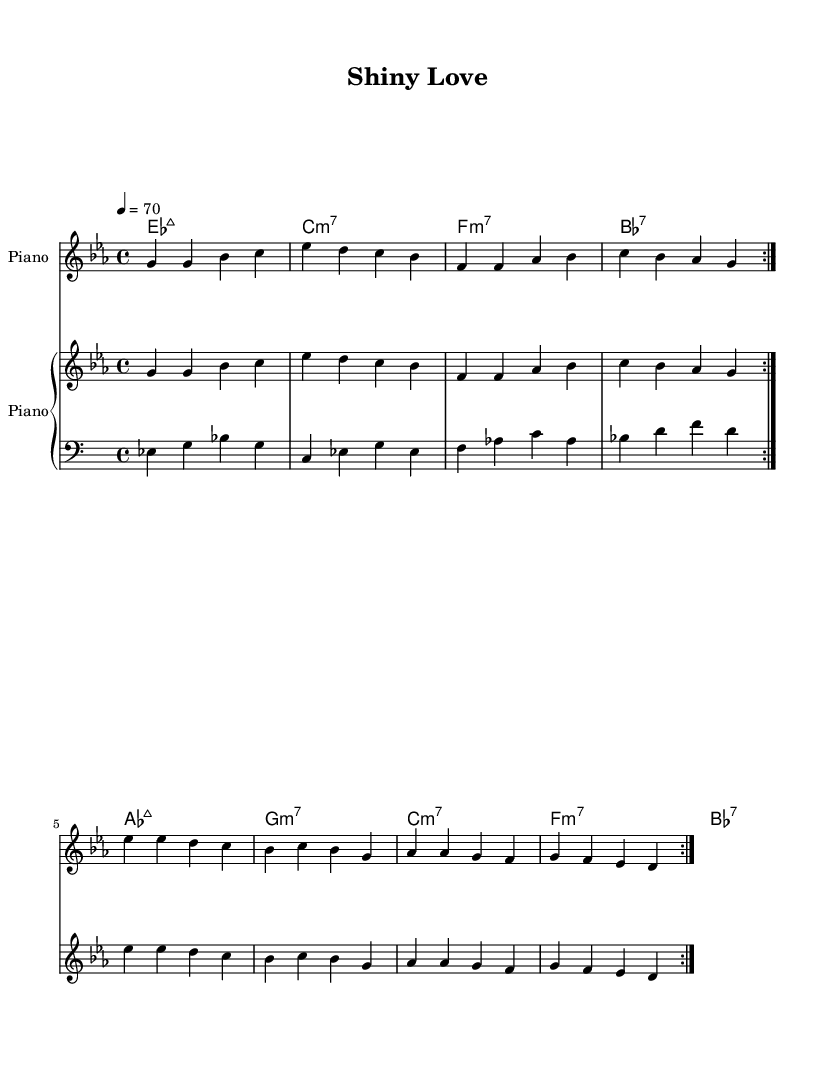What is the key signature of this music? The key signature is indicated at the beginning of the score. A sigil with three flats (B, E, and A) suggests the presence of these flats in the key.
Answer: E flat major What is the time signature of this music? The time signature is displayed at the start of the score, showing a fraction of 4 over 4. This indicates that there are four beats in each measure, and the quarter note receives one beat.
Answer: 4/4 What is the tempo marking for this piece? The tempo marking indicates how fast the piece should be played. Here, it is displayed as a metronomic marking of 70 beats per minute.
Answer: 70 How many times is the main melody repeated? The "repeat volta" notation indicates that the main melody section is played twice in succession. This is specified in the score prior to the melody part.
Answer: 2 What chord starts the music? The chord names are listed above the melody staff. The first chord is specified as E flat major 7, indicated in the chord naming section.
Answer: E flat major 7 What type of song structure is used in this piece? Rhythm and blues often incorporate a verse-chorus structure, characterized by repeated melodic phrases and chords. This piece also exhibits typical characteristics of a verse structure with a catchy hook.
Answer: Verse What is the dynamic marking in the piano part? In the piano staff, dynamics are typically indicated through various markings. While specific dynamics may not be shown, the lack of symbols suggests a smooth playing style, common in R&B to convey emotion.
Answer: Smooth 